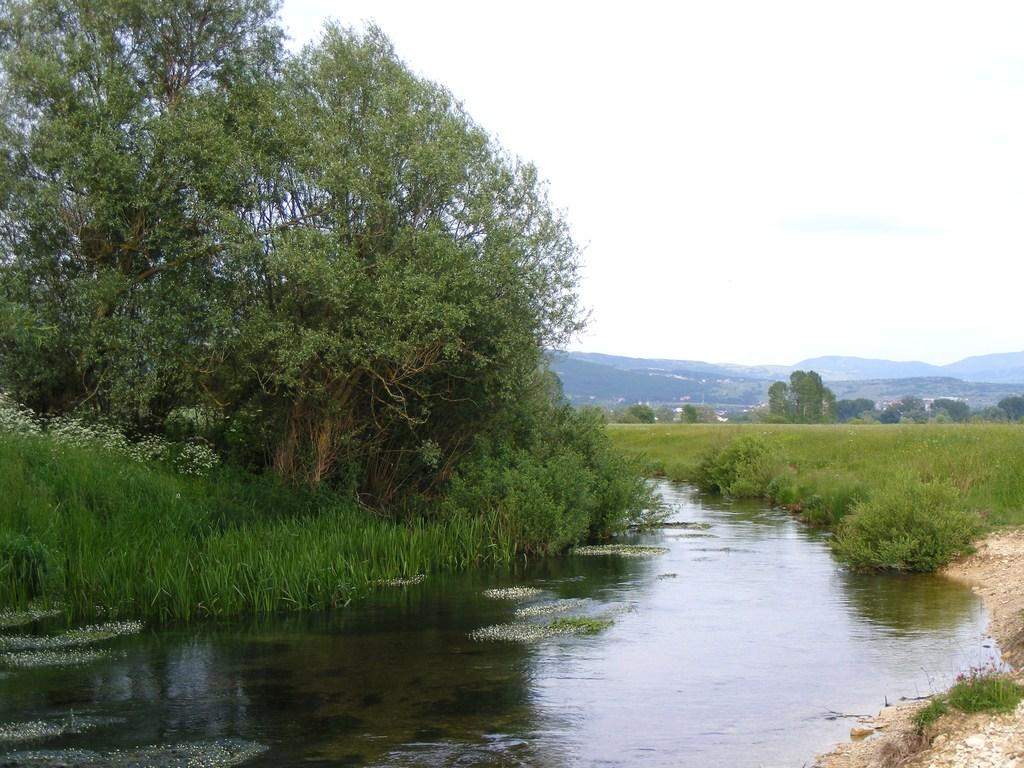What is the primary element present in the image? There is water in the image. What else can be seen besides the water? There is ground visible in the image, along with green plants and green trees. What is visible in the background of the image? There are mountains and the sky visible in the background of the image. What type of shoes can be seen in the image? There are no shoes present in the image. Can you describe the facial expression of the trees in the image? Trees do not have facial expressions, so it is not possible to describe their expressions in the image. 